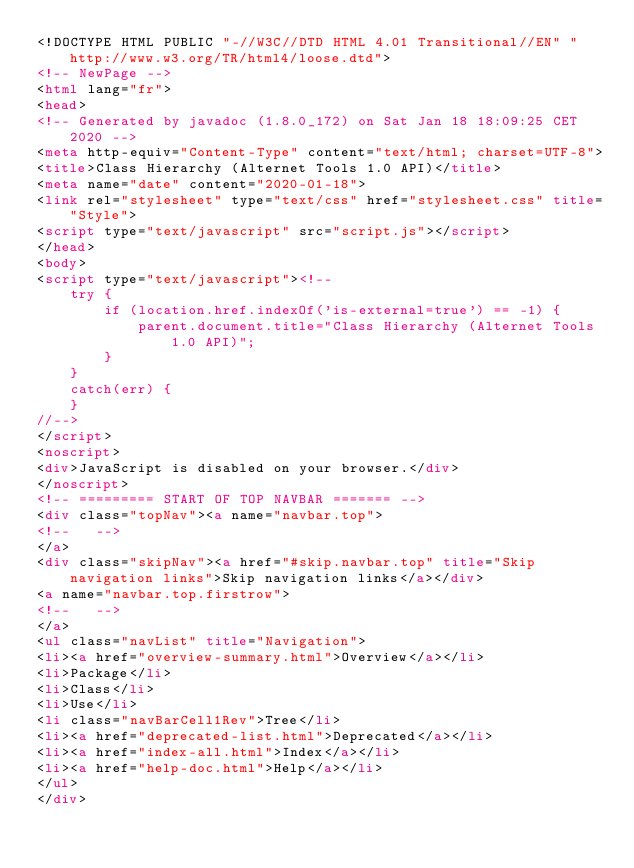Convert code to text. <code><loc_0><loc_0><loc_500><loc_500><_HTML_><!DOCTYPE HTML PUBLIC "-//W3C//DTD HTML 4.01 Transitional//EN" "http://www.w3.org/TR/html4/loose.dtd">
<!-- NewPage -->
<html lang="fr">
<head>
<!-- Generated by javadoc (1.8.0_172) on Sat Jan 18 18:09:25 CET 2020 -->
<meta http-equiv="Content-Type" content="text/html; charset=UTF-8">
<title>Class Hierarchy (Alternet Tools 1.0 API)</title>
<meta name="date" content="2020-01-18">
<link rel="stylesheet" type="text/css" href="stylesheet.css" title="Style">
<script type="text/javascript" src="script.js"></script>
</head>
<body>
<script type="text/javascript"><!--
    try {
        if (location.href.indexOf('is-external=true') == -1) {
            parent.document.title="Class Hierarchy (Alternet Tools 1.0 API)";
        }
    }
    catch(err) {
    }
//-->
</script>
<noscript>
<div>JavaScript is disabled on your browser.</div>
</noscript>
<!-- ========= START OF TOP NAVBAR ======= -->
<div class="topNav"><a name="navbar.top">
<!--   -->
</a>
<div class="skipNav"><a href="#skip.navbar.top" title="Skip navigation links">Skip navigation links</a></div>
<a name="navbar.top.firstrow">
<!--   -->
</a>
<ul class="navList" title="Navigation">
<li><a href="overview-summary.html">Overview</a></li>
<li>Package</li>
<li>Class</li>
<li>Use</li>
<li class="navBarCell1Rev">Tree</li>
<li><a href="deprecated-list.html">Deprecated</a></li>
<li><a href="index-all.html">Index</a></li>
<li><a href="help-doc.html">Help</a></li>
</ul>
</div></code> 